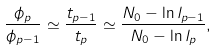<formula> <loc_0><loc_0><loc_500><loc_500>\frac { \phi _ { p } } { \phi _ { p - 1 } } \simeq \frac { t _ { p - 1 } } { t _ { p } } \simeq \frac { { N _ { 0 } - \ln l _ { p - 1 } } } { { N _ { 0 } - \ln l _ { p } } } ,</formula> 